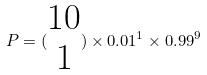Convert formula to latex. <formula><loc_0><loc_0><loc_500><loc_500>P = ( \begin{matrix} 1 0 \\ 1 \end{matrix} ) \times 0 . 0 1 ^ { 1 } \times 0 . 9 9 ^ { 9 }</formula> 